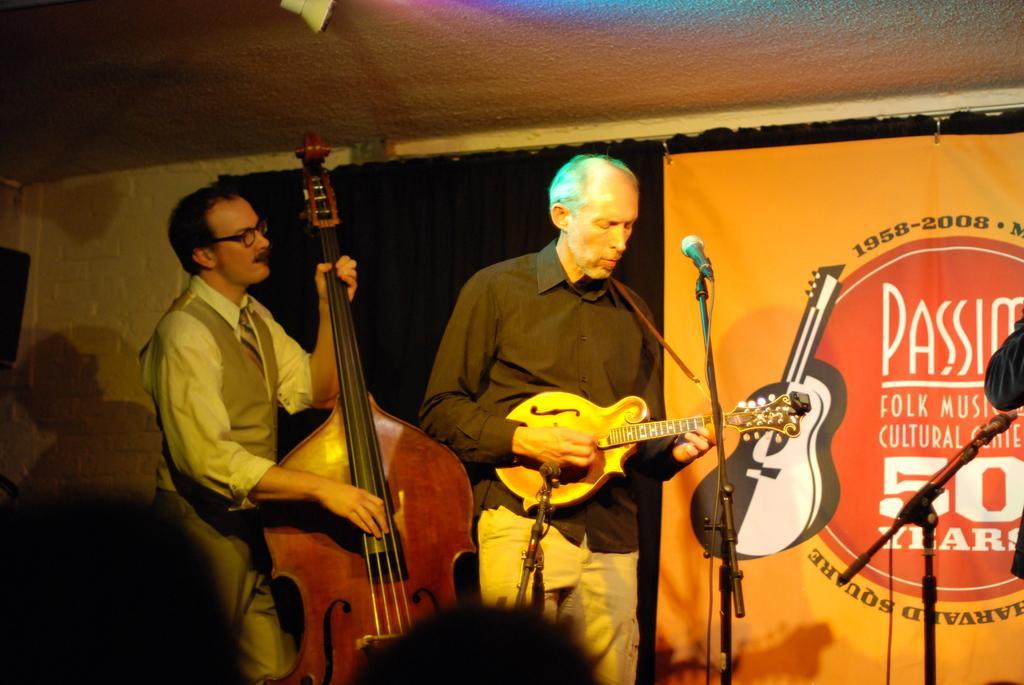Can you describe this image briefly? In this image I can see a person wearing a shirt and a pant Standing and holding a musical instrument in his hand in front of a microphone, to the left of the image i can see another person standing and holding a musical instrument in his hand. In the background I can see the ceiling, the wall ,a curtain, a banner and a microphone. 